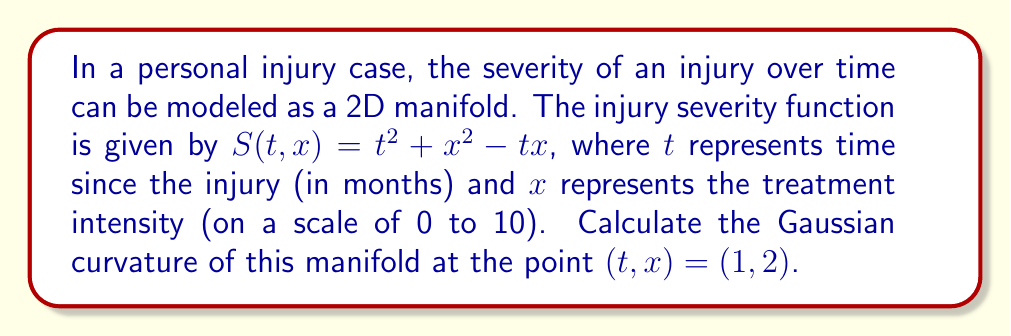Show me your answer to this math problem. To calculate the Gaussian curvature of the 2D manifold representing injury severity, we'll follow these steps:

1) The Gaussian curvature K is given by:

   $$K = \frac{LN - M^2}{EG - F^2}$$

   where L, M, N are coefficients of the second fundamental form, and E, F, G are coefficients of the first fundamental form.

2) First, let's calculate the partial derivatives:

   $$S_t = 2t - x$$
   $$S_x = 2x - t$$
   $$S_{tt} = 2$$
   $$S_{xx} = 2$$
   $$S_{tx} = S_{xt} = -1$$

3) Now, we can calculate E, F, and G:

   $$E = 1 + S_t^2 = 1 + (2t - x)^2$$
   $$F = S_t S_x = (2t - x)(2x - t)$$
   $$G = 1 + S_x^2 = 1 + (2x - t)^2$$

4) Next, we calculate the unit normal vector:

   $$\vec{N} = \frac{(-S_t, -S_x, 1)}{\sqrt{1 + S_t^2 + S_x^2}}$$

5) Now we can calculate L, M, and N:

   $$L = \frac{S_{tt}}{\sqrt{1 + S_t^2 + S_x^2}} = \frac{2}{\sqrt{1 + S_t^2 + S_x^2}}$$
   
   $$M = \frac{S_{tx}}{\sqrt{1 + S_t^2 + S_x^2}} = \frac{-1}{\sqrt{1 + S_t^2 + S_x^2}}$$
   
   $$N = \frac{S_{xx}}{\sqrt{1 + S_t^2 + S_x^2}} = \frac{2}{\sqrt{1 + S_t^2 + S_x^2}}$$

6) At the point (1,2), we have:

   $$S_t = 2(1) - 2 = 0$$
   $$S_x = 2(2) - 1 = 3$$

   $$E = 1 + 0^2 = 1$$
   $$F = 0 \cdot 3 = 0$$
   $$G = 1 + 3^2 = 10$$

   $$L = M = N = \frac{2}{\sqrt{1 + 0^2 + 3^2}} = \frac{2}{\sqrt{10}}$$

7) Now we can calculate the Gaussian curvature:

   $$K = \frac{LN - M^2}{EG - F^2} = \frac{(\frac{2}{\sqrt{10}})(\frac{2}{\sqrt{10}}) - (\frac{-1}{\sqrt{10}})^2}{1(10) - 0^2} = \frac{\frac{4}{10} + \frac{1}{10}}{10} = \frac{1}{20} = 0.05$$
Answer: The Gaussian curvature of the injury severity manifold at the point $(t,x) = (1,2)$ is $0.05$. 